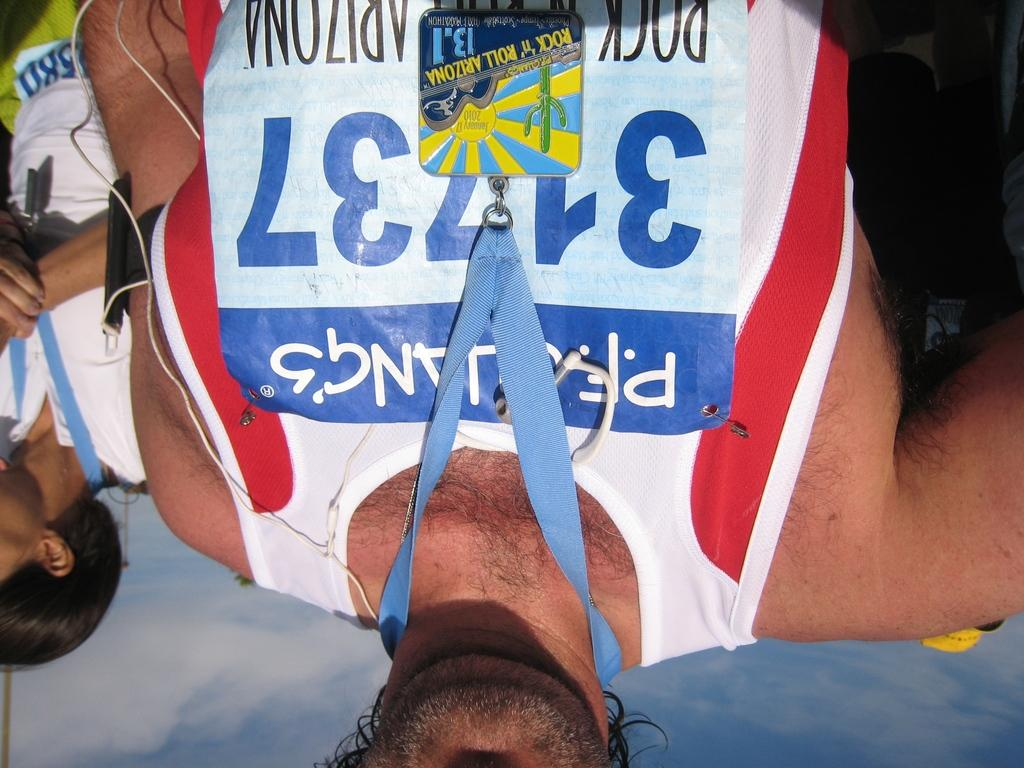<image>
Render a clear and concise summary of the photo. a man who ran a race, is wearing the number 31737 